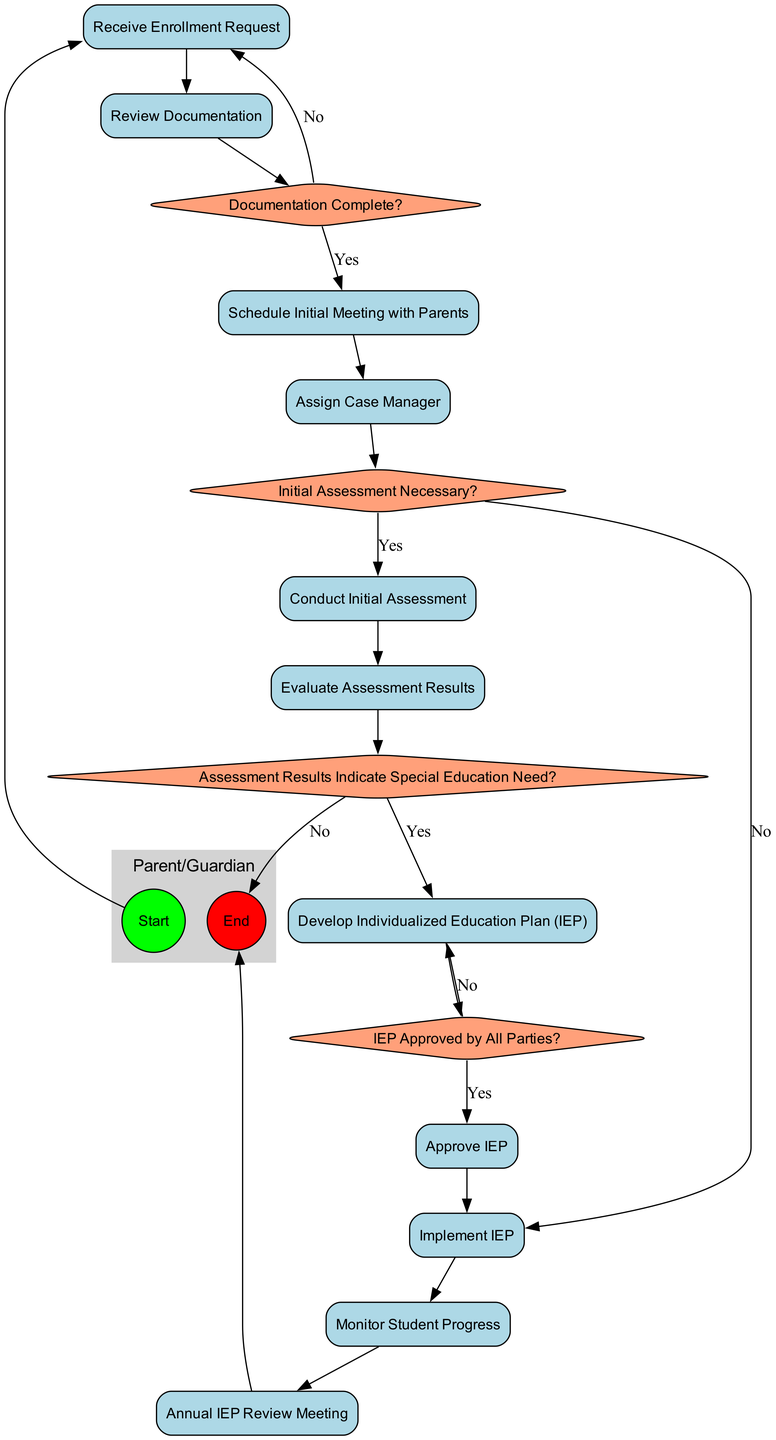What is the first action in the process? The first action starting from the "Start" node is "Receive Enrollment Request." This is determined by following the flow from the "Start" node, which directly connects to the action "Receive Enrollment Request."
Answer: Receive Enrollment Request How many decision points are there in the diagram? The diagram includes four decision points: "Documentation Complete?", "Initial Assessment Necessary?", "Assessment Results Indicate Special Education Need?", and "IEP Approved by All Parties?" This can be counted by listing the decision nodes presented in the diagram.
Answer: 4 What action follows "Review Documentation"? After "Review Documentation," the next action is "Schedule Initial Meeting with Parents," indicated by the direct connection from "Review Documentation" to that action in the diagram.
Answer: Schedule Initial Meeting with Parents Which action is taken if the "Assessment Results Indicate Special Education Need?" If the "Assessment Results Indicate Special Education Need?" is answered affirmatively, the next action taken is "Develop Individualized Education Plan (IEP)," as per the diagram's flow leading from that decision point.
Answer: Develop Individualized Education Plan (IEP) What happens if the documentation is not complete? If the documentation is not complete, the flow indicates that it returns to "Receive Enrollment Request," as there is a direct "No" edge leading back to that node.
Answer: Receive Enrollment Request What role evaluates the assessment results? The "Assessment Team" is responsible for evaluating the assessment results according to the swimlane that defines which actor is involved at each stage of the process.
Answer: Assessment Team 